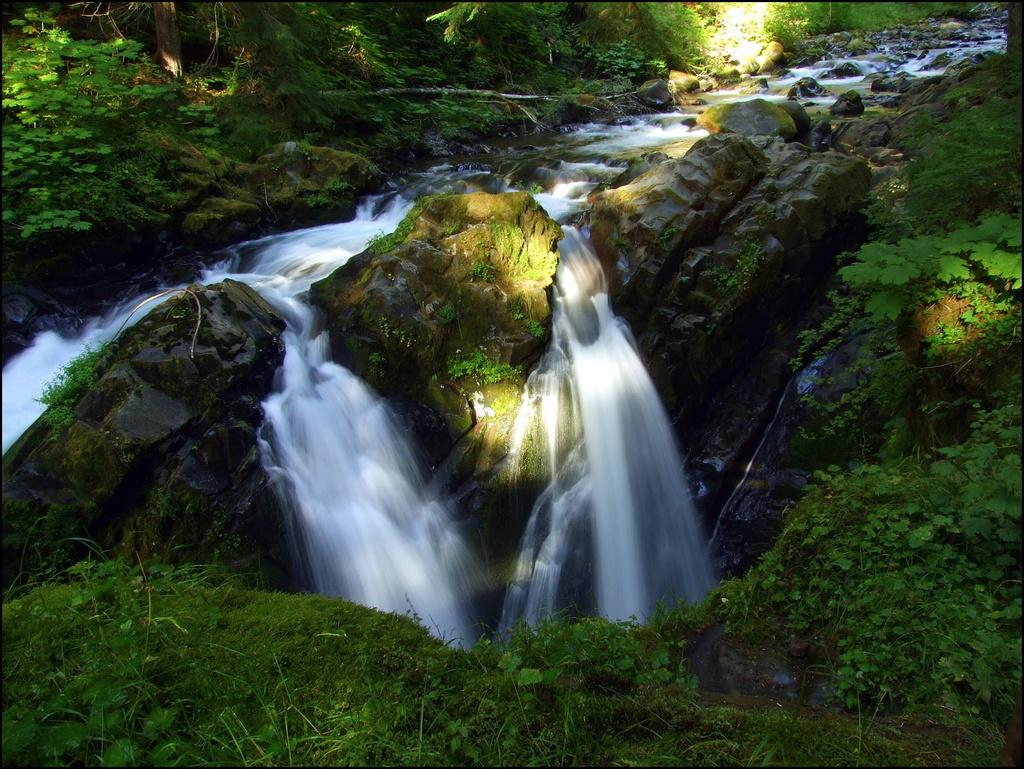What type of vegetation is present in the image? There is grass in the image. What other natural elements can be seen in the image? There are rocks and trees visible in the image. What is the water feature in the image? There is water visible in the image. Can you see the airplane joining the trees in the image? There is no airplane present in the image, so it cannot join the trees. 